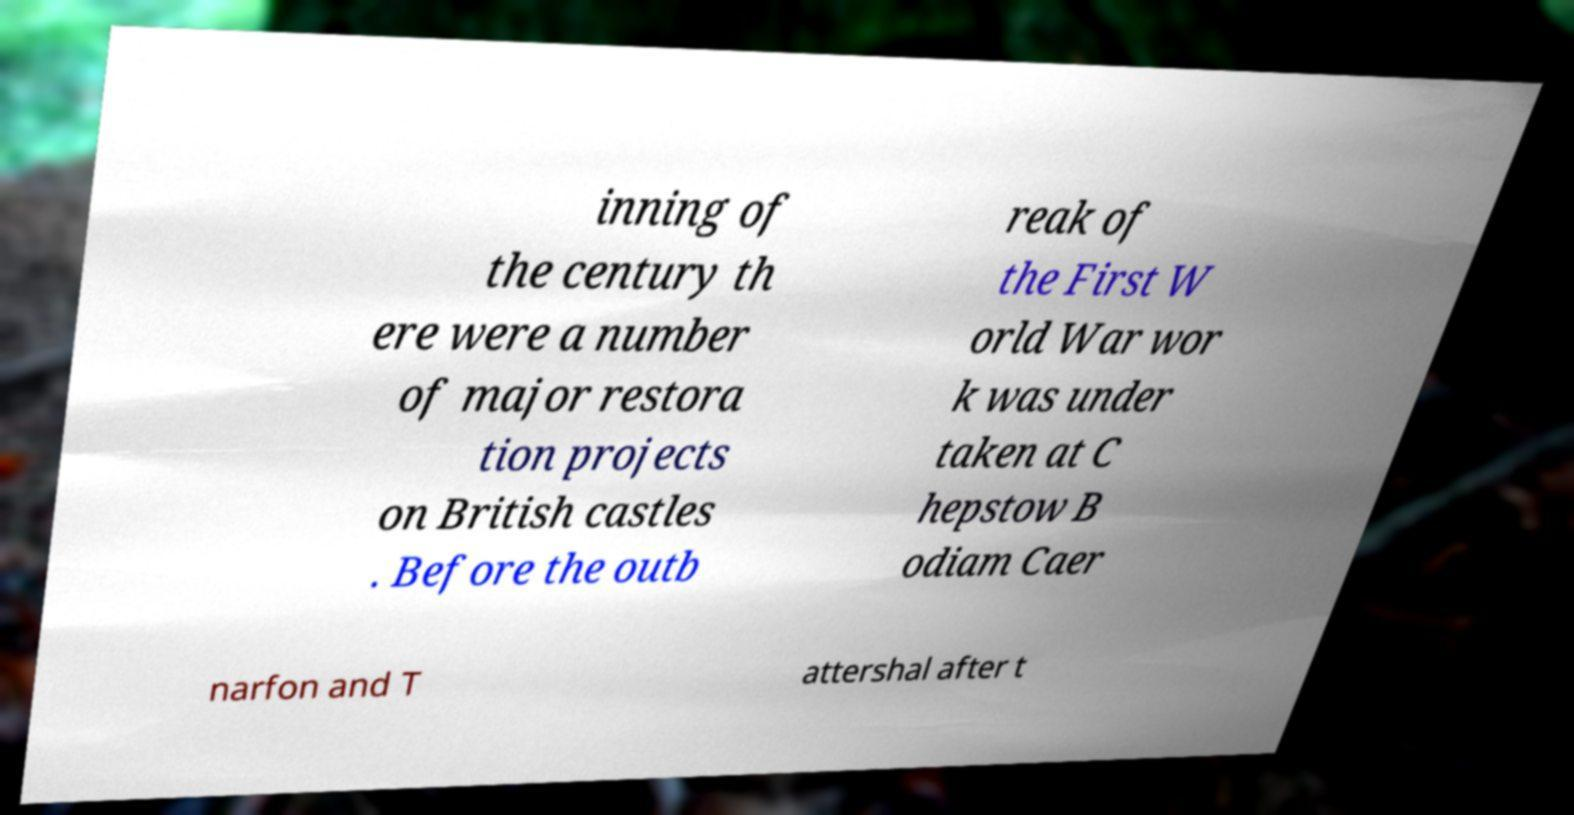Can you read and provide the text displayed in the image?This photo seems to have some interesting text. Can you extract and type it out for me? inning of the century th ere were a number of major restora tion projects on British castles . Before the outb reak of the First W orld War wor k was under taken at C hepstow B odiam Caer narfon and T attershal after t 